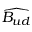Convert formula to latex. <formula><loc_0><loc_0><loc_500><loc_500>\widehat { B _ { u d } }</formula> 